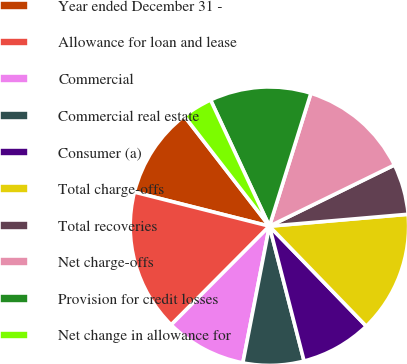<chart> <loc_0><loc_0><loc_500><loc_500><pie_chart><fcel>Year ended December 31 -<fcel>Allowance for loan and lease<fcel>Commercial<fcel>Commercial real estate<fcel>Consumer (a)<fcel>Total charge-offs<fcel>Total recoveries<fcel>Net charge-offs<fcel>Provision for credit losses<fcel>Net change in allowance for<nl><fcel>10.59%<fcel>16.47%<fcel>9.41%<fcel>7.06%<fcel>8.24%<fcel>14.12%<fcel>5.88%<fcel>12.94%<fcel>11.76%<fcel>3.53%<nl></chart> 